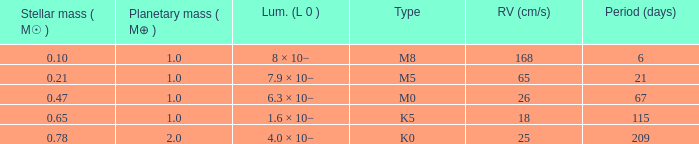21, and of the m0 category? 67.0. 